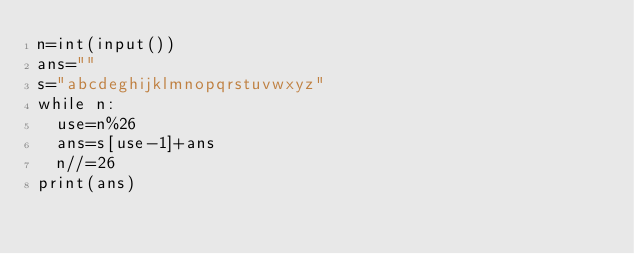Convert code to text. <code><loc_0><loc_0><loc_500><loc_500><_Python_>n=int(input())
ans=""
s="abcdeghijklmnopqrstuvwxyz"
while n:
  use=n%26
  ans=s[use-1]+ans
  n//=26
print(ans)</code> 